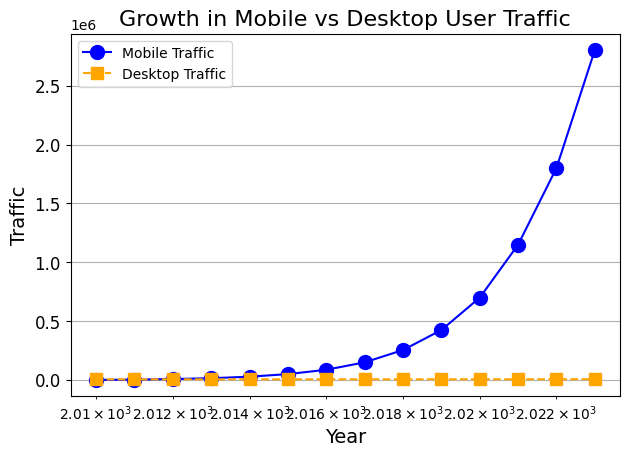What is the difference in traffic between mobile and desktop users in 2023? In 2023, the mobile traffic is 2800000 and the desktop traffic is 6400. The difference can be calculated by subtracting the desktop traffic from the mobile traffic: 2800000 - 6400 = 2793600
Answer: 2793600 Which year shows the most significant increase in mobile traffic compared to its previous year? To find the most significant increase, we look at the differences in mobile traffic year-over-year. The largest increase is seen between 2020 and 2021, where mobile traffic jumps from 700000 to 1150000. The difference is 1150000 - 700000 = 450000
Answer: 2021 Compare the mobile and desktop traffic in 2015. Which one is greater and by how much? In 2015, the mobile traffic is 50000 and the desktop traffic is 5600. Mobile traffic is greater. The difference is 50000 - 5600 = 44400
Answer: Mobile traffic by 44400 What trend can be observed in desktop traffic from 2010 to 2023? From the figure, desktop traffic shows a very slow and almost linear increase over the years, going from 5000 in 2010 to 6400 in 2023. The values barely change compared to the mobile traffic growth
Answer: Slow and linear increase How does the growth of mobile traffic compare to desktop traffic over the analyzed period? Mobile traffic shows exponential growth, increasing dramatically from 1000 in 2010 to 2800000 in 2023. In contrast, desktop traffic increases very slowly and almost linearly from 5000 to 6400 over the same period
Answer: Mobile traffic grows exponentially, desktop traffic grows linearly During which year did mobile traffic surpass 1000000? From the figure, mobile traffic reaches 1150000 in 2021, which is the first year it surpasses 1000000
Answer: 2021 Calculate the average mobile traffic value for the years 2018 to 2023. Sum the mobile traffic values from 2018 to 2023: (255000 + 425000 + 700000 + 1150000 + 1800000 + 2800000) = 7335000. There are 6 years, so the average is 7335000 / 6 = 1222500
Answer: 1222500 Identify the year(s) where desktop traffic stagnation is most apparent. The stagnation in desktop traffic appears most apparent from 2011 to 2019 where it only increases from 5200 to 6000, a minimal increase over a long period
Answer: 2011-2019 What is the ratio of mobile to desktop traffic in 2019? In 2019, mobile traffic is 425000 and desktop traffic is 6000. The ratio is 425000 / 6000 ≈ 70.83
Answer: 70.83 In which year does mobile traffic first significantly exceed 100000, and by how much? In 2016, mobile traffic is 87000, which is below 100000. In 2017, it jumps to 150000, exceeding 100000 by 150000 - 100000 = 50000
Answer: 2017, by 50000 